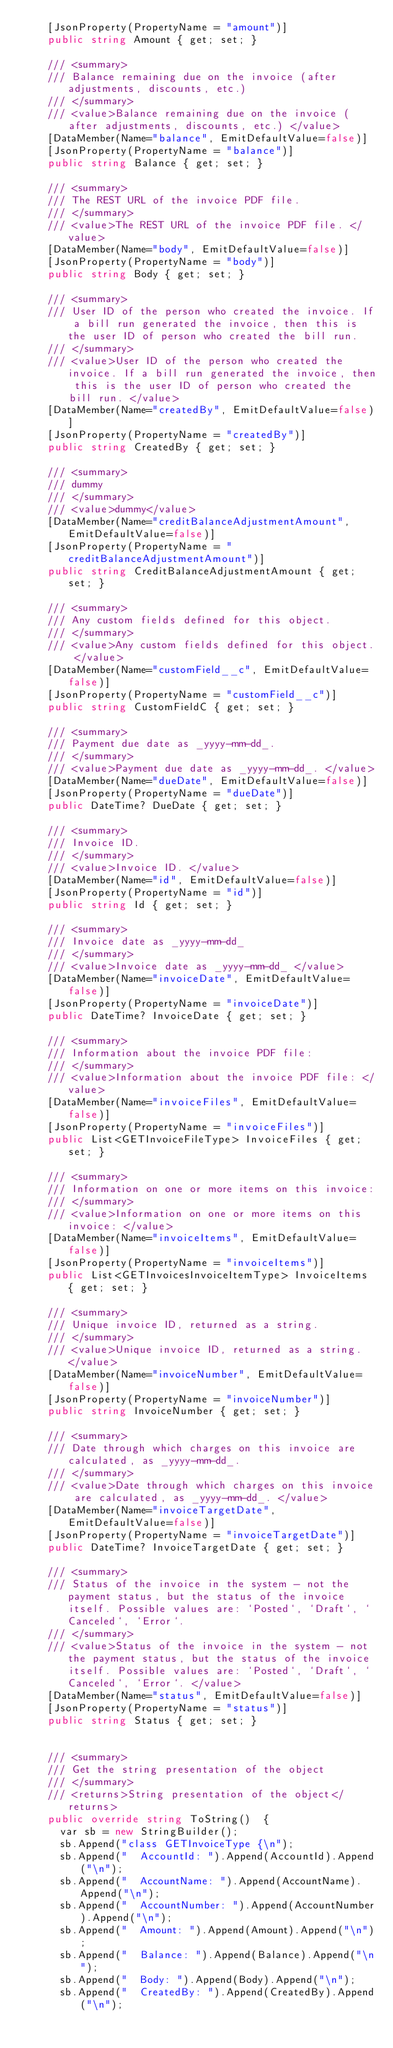Convert code to text. <code><loc_0><loc_0><loc_500><loc_500><_C#_>    [JsonProperty(PropertyName = "amount")]
    public string Amount { get; set; }

    /// <summary>
    /// Balance remaining due on the invoice (after adjustments, discounts, etc.) 
    /// </summary>
    /// <value>Balance remaining due on the invoice (after adjustments, discounts, etc.) </value>
    [DataMember(Name="balance", EmitDefaultValue=false)]
    [JsonProperty(PropertyName = "balance")]
    public string Balance { get; set; }

    /// <summary>
    /// The REST URL of the invoice PDF file. 
    /// </summary>
    /// <value>The REST URL of the invoice PDF file. </value>
    [DataMember(Name="body", EmitDefaultValue=false)]
    [JsonProperty(PropertyName = "body")]
    public string Body { get; set; }

    /// <summary>
    /// User ID of the person who created the invoice. If a bill run generated the invoice, then this is the user ID of person who created the bill run. 
    /// </summary>
    /// <value>User ID of the person who created the invoice. If a bill run generated the invoice, then this is the user ID of person who created the bill run. </value>
    [DataMember(Name="createdBy", EmitDefaultValue=false)]
    [JsonProperty(PropertyName = "createdBy")]
    public string CreatedBy { get; set; }

    /// <summary>
    /// dummy
    /// </summary>
    /// <value>dummy</value>
    [DataMember(Name="creditBalanceAdjustmentAmount", EmitDefaultValue=false)]
    [JsonProperty(PropertyName = "creditBalanceAdjustmentAmount")]
    public string CreditBalanceAdjustmentAmount { get; set; }

    /// <summary>
    /// Any custom fields defined for this object. 
    /// </summary>
    /// <value>Any custom fields defined for this object. </value>
    [DataMember(Name="customField__c", EmitDefaultValue=false)]
    [JsonProperty(PropertyName = "customField__c")]
    public string CustomFieldC { get; set; }

    /// <summary>
    /// Payment due date as _yyyy-mm-dd_. 
    /// </summary>
    /// <value>Payment due date as _yyyy-mm-dd_. </value>
    [DataMember(Name="dueDate", EmitDefaultValue=false)]
    [JsonProperty(PropertyName = "dueDate")]
    public DateTime? DueDate { get; set; }

    /// <summary>
    /// Invoice ID. 
    /// </summary>
    /// <value>Invoice ID. </value>
    [DataMember(Name="id", EmitDefaultValue=false)]
    [JsonProperty(PropertyName = "id")]
    public string Id { get; set; }

    /// <summary>
    /// Invoice date as _yyyy-mm-dd_ 
    /// </summary>
    /// <value>Invoice date as _yyyy-mm-dd_ </value>
    [DataMember(Name="invoiceDate", EmitDefaultValue=false)]
    [JsonProperty(PropertyName = "invoiceDate")]
    public DateTime? InvoiceDate { get; set; }

    /// <summary>
    /// Information about the invoice PDF file: 
    /// </summary>
    /// <value>Information about the invoice PDF file: </value>
    [DataMember(Name="invoiceFiles", EmitDefaultValue=false)]
    [JsonProperty(PropertyName = "invoiceFiles")]
    public List<GETInvoiceFileType> InvoiceFiles { get; set; }

    /// <summary>
    /// Information on one or more items on this invoice: 
    /// </summary>
    /// <value>Information on one or more items on this invoice: </value>
    [DataMember(Name="invoiceItems", EmitDefaultValue=false)]
    [JsonProperty(PropertyName = "invoiceItems")]
    public List<GETInvoicesInvoiceItemType> InvoiceItems { get; set; }

    /// <summary>
    /// Unique invoice ID, returned as a string. 
    /// </summary>
    /// <value>Unique invoice ID, returned as a string. </value>
    [DataMember(Name="invoiceNumber", EmitDefaultValue=false)]
    [JsonProperty(PropertyName = "invoiceNumber")]
    public string InvoiceNumber { get; set; }

    /// <summary>
    /// Date through which charges on this invoice are calculated, as _yyyy-mm-dd_. 
    /// </summary>
    /// <value>Date through which charges on this invoice are calculated, as _yyyy-mm-dd_. </value>
    [DataMember(Name="invoiceTargetDate", EmitDefaultValue=false)]
    [JsonProperty(PropertyName = "invoiceTargetDate")]
    public DateTime? InvoiceTargetDate { get; set; }

    /// <summary>
    /// Status of the invoice in the system - not the payment status, but the status of the invoice itself. Possible values are: `Posted`, `Draft`, `Canceled`, `Error`. 
    /// </summary>
    /// <value>Status of the invoice in the system - not the payment status, but the status of the invoice itself. Possible values are: `Posted`, `Draft`, `Canceled`, `Error`. </value>
    [DataMember(Name="status", EmitDefaultValue=false)]
    [JsonProperty(PropertyName = "status")]
    public string Status { get; set; }


    /// <summary>
    /// Get the string presentation of the object
    /// </summary>
    /// <returns>String presentation of the object</returns>
    public override string ToString()  {
      var sb = new StringBuilder();
      sb.Append("class GETInvoiceType {\n");
      sb.Append("  AccountId: ").Append(AccountId).Append("\n");
      sb.Append("  AccountName: ").Append(AccountName).Append("\n");
      sb.Append("  AccountNumber: ").Append(AccountNumber).Append("\n");
      sb.Append("  Amount: ").Append(Amount).Append("\n");
      sb.Append("  Balance: ").Append(Balance).Append("\n");
      sb.Append("  Body: ").Append(Body).Append("\n");
      sb.Append("  CreatedBy: ").Append(CreatedBy).Append("\n");</code> 